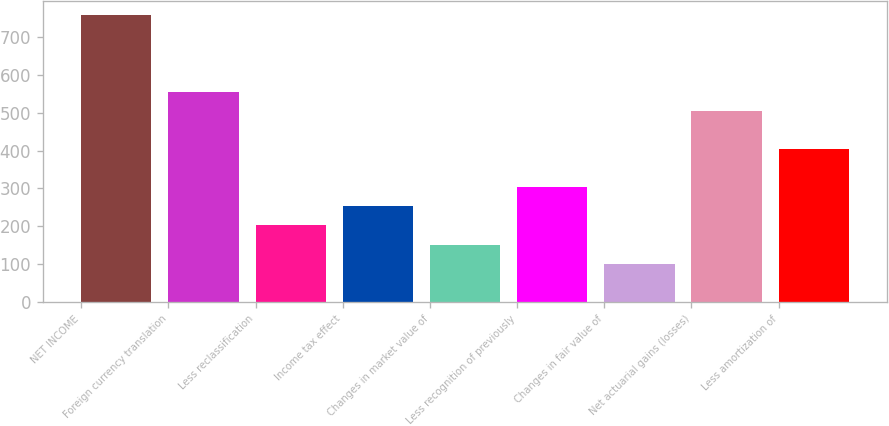Convert chart. <chart><loc_0><loc_0><loc_500><loc_500><bar_chart><fcel>NET INCOME<fcel>Foreign currency translation<fcel>Less reclassification<fcel>Income tax effect<fcel>Changes in market value of<fcel>Less recognition of previously<fcel>Changes in fair value of<fcel>Net actuarial gains (losses)<fcel>Less amortization of<nl><fcel>757.85<fcel>555.89<fcel>202.46<fcel>252.95<fcel>151.97<fcel>303.44<fcel>101.48<fcel>505.4<fcel>404.42<nl></chart> 